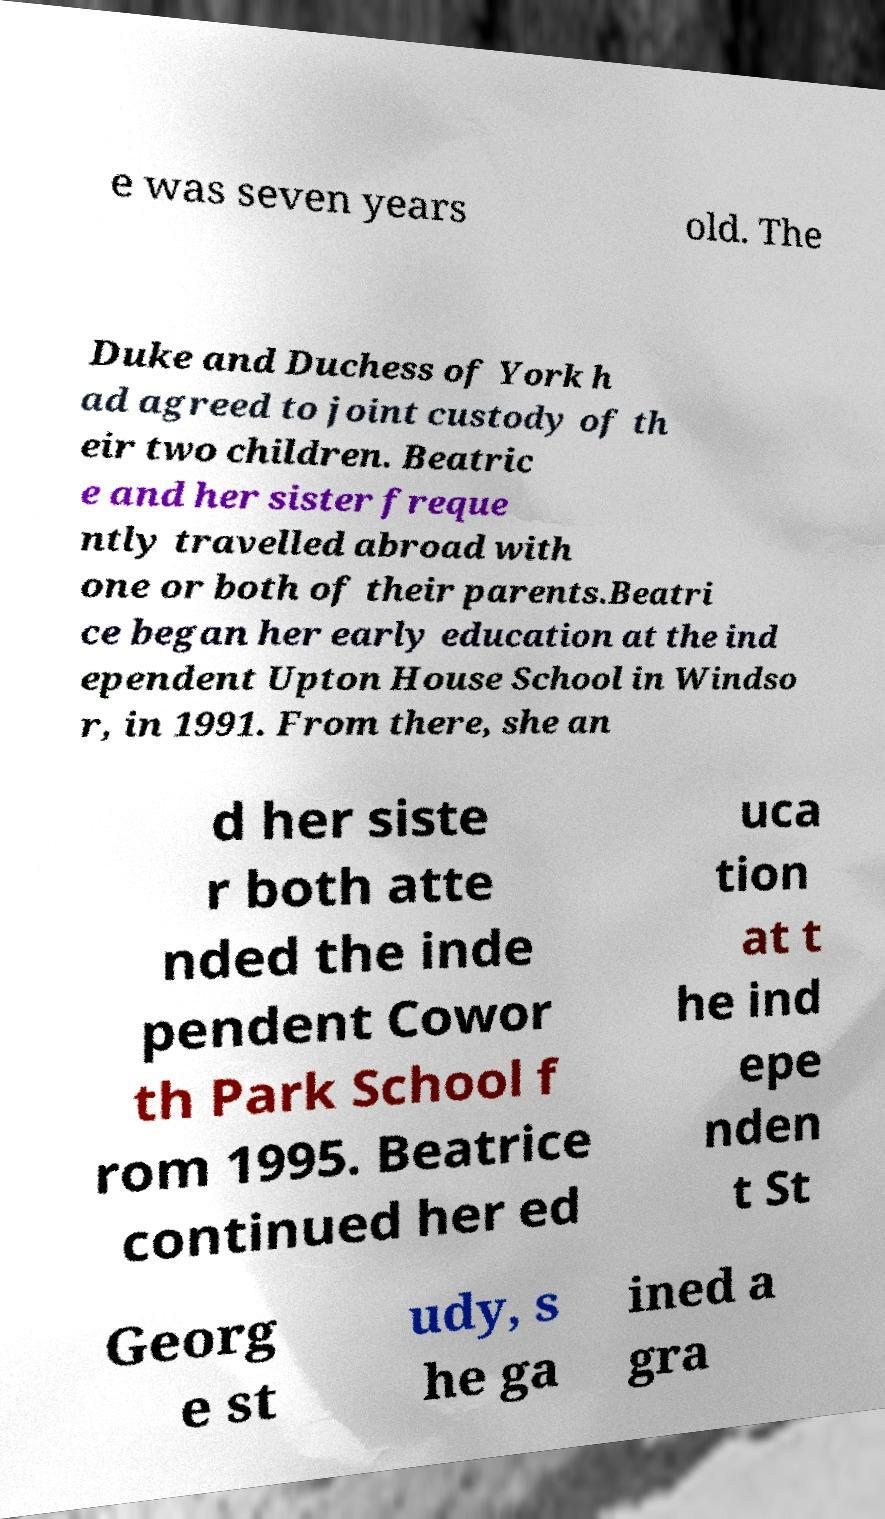I need the written content from this picture converted into text. Can you do that? e was seven years old. The Duke and Duchess of York h ad agreed to joint custody of th eir two children. Beatric e and her sister freque ntly travelled abroad with one or both of their parents.Beatri ce began her early education at the ind ependent Upton House School in Windso r, in 1991. From there, she an d her siste r both atte nded the inde pendent Cowor th Park School f rom 1995. Beatrice continued her ed uca tion at t he ind epe nden t St Georg e st udy, s he ga ined a gra 